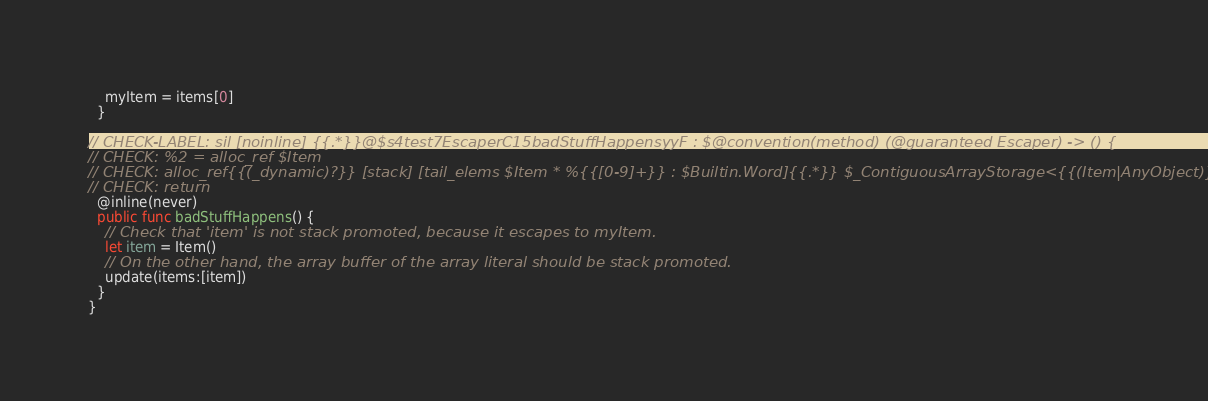Convert code to text. <code><loc_0><loc_0><loc_500><loc_500><_Swift_>    myItem = items[0]
  }

// CHECK-LABEL: sil [noinline] {{.*}}@$s4test7EscaperC15badStuffHappensyyF : $@convention(method) (@guaranteed Escaper) -> () {
// CHECK: %2 = alloc_ref $Item
// CHECK: alloc_ref{{(_dynamic)?}} [stack] [tail_elems $Item * %{{[0-9]+}} : $Builtin.Word]{{.*}} $_ContiguousArrayStorage<{{(Item|AnyObject)}}>
// CHECK: return
  @inline(never)
  public func badStuffHappens() {
    // Check that 'item' is not stack promoted, because it escapes to myItem.
    let item = Item()
    // On the other hand, the array buffer of the array literal should be stack promoted.
    update(items:[item])
  }
}

</code> 